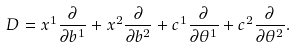<formula> <loc_0><loc_0><loc_500><loc_500>D = x ^ { 1 } \frac { \partial } { \partial b ^ { 1 } } + x ^ { 2 } \frac { \partial } { \partial b ^ { 2 } } + c ^ { 1 } \frac { \partial } { \partial \theta ^ { 1 } } + c ^ { 2 } \frac { \partial } { \partial \theta ^ { 2 } } .</formula> 